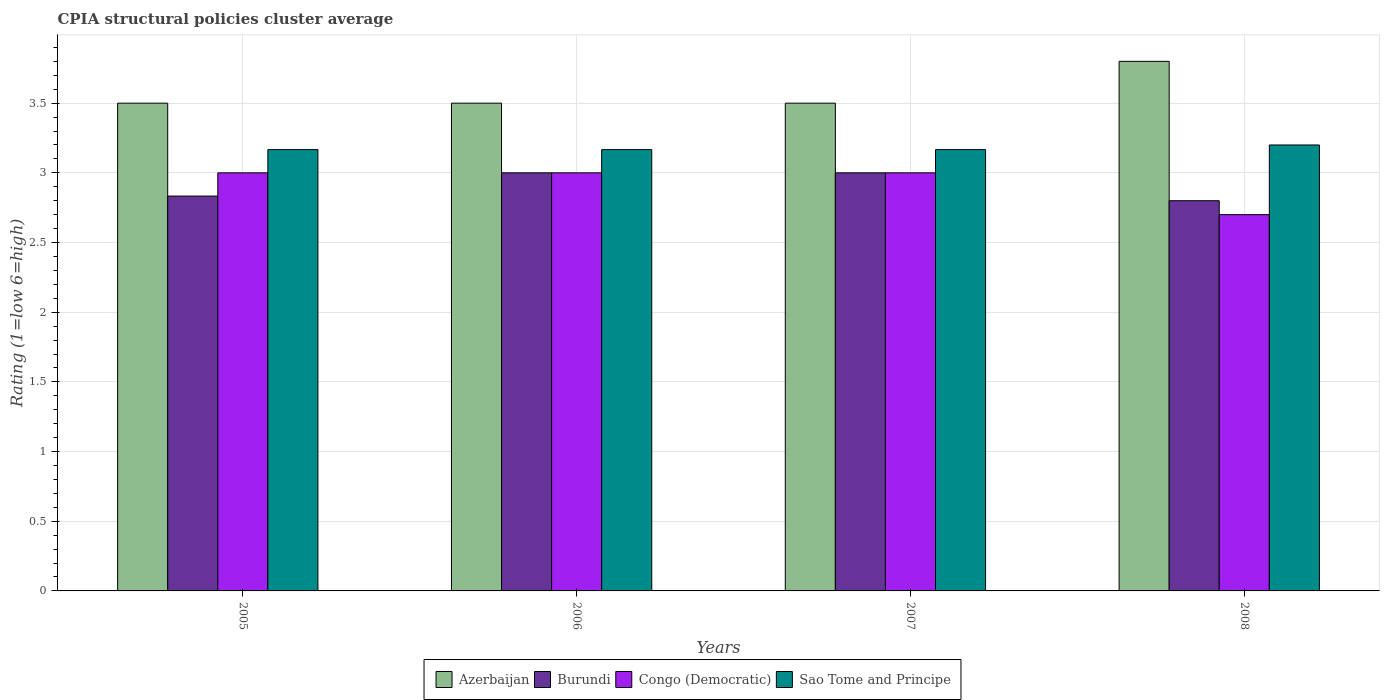How many different coloured bars are there?
Keep it short and to the point. 4. Are the number of bars per tick equal to the number of legend labels?
Offer a terse response. Yes. How many bars are there on the 4th tick from the right?
Your answer should be very brief. 4. What is the label of the 2nd group of bars from the left?
Offer a very short reply. 2006. Across all years, what is the maximum CPIA rating in Congo (Democratic)?
Make the answer very short. 3. Across all years, what is the minimum CPIA rating in Azerbaijan?
Provide a short and direct response. 3.5. In which year was the CPIA rating in Burundi minimum?
Offer a very short reply. 2008. What is the total CPIA rating in Congo (Democratic) in the graph?
Offer a terse response. 11.7. What is the difference between the CPIA rating in Azerbaijan in 2005 and that in 2006?
Keep it short and to the point. 0. What is the average CPIA rating in Sao Tome and Principe per year?
Your answer should be very brief. 3.18. In how many years, is the CPIA rating in Burundi greater than 0.6?
Ensure brevity in your answer.  4. What is the ratio of the CPIA rating in Azerbaijan in 2005 to that in 2008?
Your answer should be very brief. 0.92. What is the difference between the highest and the lowest CPIA rating in Burundi?
Ensure brevity in your answer.  0.2. Is the sum of the CPIA rating in Congo (Democratic) in 2006 and 2007 greater than the maximum CPIA rating in Azerbaijan across all years?
Keep it short and to the point. Yes. Is it the case that in every year, the sum of the CPIA rating in Azerbaijan and CPIA rating in Congo (Democratic) is greater than the sum of CPIA rating in Sao Tome and Principe and CPIA rating in Burundi?
Provide a succinct answer. No. What does the 2nd bar from the left in 2008 represents?
Provide a short and direct response. Burundi. What does the 2nd bar from the right in 2007 represents?
Ensure brevity in your answer.  Congo (Democratic). Is it the case that in every year, the sum of the CPIA rating in Sao Tome and Principe and CPIA rating in Azerbaijan is greater than the CPIA rating in Congo (Democratic)?
Give a very brief answer. Yes. Does the graph contain any zero values?
Keep it short and to the point. No. How are the legend labels stacked?
Offer a very short reply. Horizontal. What is the title of the graph?
Provide a succinct answer. CPIA structural policies cluster average. Does "Belize" appear as one of the legend labels in the graph?
Provide a short and direct response. No. What is the label or title of the X-axis?
Keep it short and to the point. Years. What is the label or title of the Y-axis?
Your answer should be compact. Rating (1=low 6=high). What is the Rating (1=low 6=high) of Azerbaijan in 2005?
Keep it short and to the point. 3.5. What is the Rating (1=low 6=high) in Burundi in 2005?
Offer a terse response. 2.83. What is the Rating (1=low 6=high) of Sao Tome and Principe in 2005?
Ensure brevity in your answer.  3.17. What is the Rating (1=low 6=high) in Burundi in 2006?
Give a very brief answer. 3. What is the Rating (1=low 6=high) in Congo (Democratic) in 2006?
Provide a succinct answer. 3. What is the Rating (1=low 6=high) in Sao Tome and Principe in 2006?
Your answer should be very brief. 3.17. What is the Rating (1=low 6=high) of Sao Tome and Principe in 2007?
Your response must be concise. 3.17. What is the Rating (1=low 6=high) in Burundi in 2008?
Your answer should be compact. 2.8. What is the Rating (1=low 6=high) of Congo (Democratic) in 2008?
Your response must be concise. 2.7. Across all years, what is the maximum Rating (1=low 6=high) in Azerbaijan?
Offer a very short reply. 3.8. Across all years, what is the minimum Rating (1=low 6=high) of Azerbaijan?
Ensure brevity in your answer.  3.5. Across all years, what is the minimum Rating (1=low 6=high) in Congo (Democratic)?
Offer a very short reply. 2.7. Across all years, what is the minimum Rating (1=low 6=high) of Sao Tome and Principe?
Make the answer very short. 3.17. What is the total Rating (1=low 6=high) of Burundi in the graph?
Give a very brief answer. 11.63. What is the total Rating (1=low 6=high) of Congo (Democratic) in the graph?
Ensure brevity in your answer.  11.7. What is the total Rating (1=low 6=high) of Sao Tome and Principe in the graph?
Your answer should be compact. 12.7. What is the difference between the Rating (1=low 6=high) of Sao Tome and Principe in 2005 and that in 2006?
Keep it short and to the point. 0. What is the difference between the Rating (1=low 6=high) in Burundi in 2005 and that in 2007?
Offer a terse response. -0.17. What is the difference between the Rating (1=low 6=high) of Congo (Democratic) in 2005 and that in 2007?
Your response must be concise. 0. What is the difference between the Rating (1=low 6=high) in Burundi in 2005 and that in 2008?
Your answer should be compact. 0.03. What is the difference between the Rating (1=low 6=high) in Congo (Democratic) in 2005 and that in 2008?
Make the answer very short. 0.3. What is the difference between the Rating (1=low 6=high) in Sao Tome and Principe in 2005 and that in 2008?
Offer a very short reply. -0.03. What is the difference between the Rating (1=low 6=high) of Burundi in 2006 and that in 2007?
Keep it short and to the point. 0. What is the difference between the Rating (1=low 6=high) of Burundi in 2006 and that in 2008?
Make the answer very short. 0.2. What is the difference between the Rating (1=low 6=high) in Congo (Democratic) in 2006 and that in 2008?
Your response must be concise. 0.3. What is the difference between the Rating (1=low 6=high) of Sao Tome and Principe in 2006 and that in 2008?
Provide a succinct answer. -0.03. What is the difference between the Rating (1=low 6=high) in Azerbaijan in 2007 and that in 2008?
Offer a very short reply. -0.3. What is the difference between the Rating (1=low 6=high) in Burundi in 2007 and that in 2008?
Provide a succinct answer. 0.2. What is the difference between the Rating (1=low 6=high) of Sao Tome and Principe in 2007 and that in 2008?
Ensure brevity in your answer.  -0.03. What is the difference between the Rating (1=low 6=high) of Azerbaijan in 2005 and the Rating (1=low 6=high) of Sao Tome and Principe in 2006?
Provide a short and direct response. 0.33. What is the difference between the Rating (1=low 6=high) in Burundi in 2005 and the Rating (1=low 6=high) in Sao Tome and Principe in 2006?
Give a very brief answer. -0.33. What is the difference between the Rating (1=low 6=high) in Congo (Democratic) in 2005 and the Rating (1=low 6=high) in Sao Tome and Principe in 2006?
Keep it short and to the point. -0.17. What is the difference between the Rating (1=low 6=high) of Azerbaijan in 2005 and the Rating (1=low 6=high) of Burundi in 2007?
Ensure brevity in your answer.  0.5. What is the difference between the Rating (1=low 6=high) of Azerbaijan in 2005 and the Rating (1=low 6=high) of Congo (Democratic) in 2007?
Offer a very short reply. 0.5. What is the difference between the Rating (1=low 6=high) of Azerbaijan in 2005 and the Rating (1=low 6=high) of Sao Tome and Principe in 2007?
Offer a terse response. 0.33. What is the difference between the Rating (1=low 6=high) in Burundi in 2005 and the Rating (1=low 6=high) in Congo (Democratic) in 2007?
Provide a short and direct response. -0.17. What is the difference between the Rating (1=low 6=high) of Burundi in 2005 and the Rating (1=low 6=high) of Sao Tome and Principe in 2007?
Make the answer very short. -0.33. What is the difference between the Rating (1=low 6=high) in Congo (Democratic) in 2005 and the Rating (1=low 6=high) in Sao Tome and Principe in 2007?
Keep it short and to the point. -0.17. What is the difference between the Rating (1=low 6=high) of Azerbaijan in 2005 and the Rating (1=low 6=high) of Burundi in 2008?
Provide a succinct answer. 0.7. What is the difference between the Rating (1=low 6=high) in Azerbaijan in 2005 and the Rating (1=low 6=high) in Congo (Democratic) in 2008?
Keep it short and to the point. 0.8. What is the difference between the Rating (1=low 6=high) in Azerbaijan in 2005 and the Rating (1=low 6=high) in Sao Tome and Principe in 2008?
Offer a very short reply. 0.3. What is the difference between the Rating (1=low 6=high) in Burundi in 2005 and the Rating (1=low 6=high) in Congo (Democratic) in 2008?
Keep it short and to the point. 0.13. What is the difference between the Rating (1=low 6=high) of Burundi in 2005 and the Rating (1=low 6=high) of Sao Tome and Principe in 2008?
Your answer should be very brief. -0.37. What is the difference between the Rating (1=low 6=high) of Congo (Democratic) in 2005 and the Rating (1=low 6=high) of Sao Tome and Principe in 2008?
Your answer should be compact. -0.2. What is the difference between the Rating (1=low 6=high) of Azerbaijan in 2006 and the Rating (1=low 6=high) of Burundi in 2007?
Provide a short and direct response. 0.5. What is the difference between the Rating (1=low 6=high) in Burundi in 2006 and the Rating (1=low 6=high) in Sao Tome and Principe in 2007?
Your answer should be very brief. -0.17. What is the difference between the Rating (1=low 6=high) of Congo (Democratic) in 2006 and the Rating (1=low 6=high) of Sao Tome and Principe in 2007?
Keep it short and to the point. -0.17. What is the difference between the Rating (1=low 6=high) in Azerbaijan in 2006 and the Rating (1=low 6=high) in Sao Tome and Principe in 2008?
Offer a terse response. 0.3. What is the difference between the Rating (1=low 6=high) in Burundi in 2006 and the Rating (1=low 6=high) in Congo (Democratic) in 2008?
Provide a short and direct response. 0.3. What is the difference between the Rating (1=low 6=high) of Congo (Democratic) in 2006 and the Rating (1=low 6=high) of Sao Tome and Principe in 2008?
Ensure brevity in your answer.  -0.2. What is the difference between the Rating (1=low 6=high) of Burundi in 2007 and the Rating (1=low 6=high) of Congo (Democratic) in 2008?
Provide a succinct answer. 0.3. What is the average Rating (1=low 6=high) in Azerbaijan per year?
Provide a succinct answer. 3.58. What is the average Rating (1=low 6=high) in Burundi per year?
Offer a terse response. 2.91. What is the average Rating (1=low 6=high) of Congo (Democratic) per year?
Offer a very short reply. 2.92. What is the average Rating (1=low 6=high) in Sao Tome and Principe per year?
Keep it short and to the point. 3.17. In the year 2005, what is the difference between the Rating (1=low 6=high) in Azerbaijan and Rating (1=low 6=high) in Sao Tome and Principe?
Keep it short and to the point. 0.33. In the year 2005, what is the difference between the Rating (1=low 6=high) in Burundi and Rating (1=low 6=high) in Congo (Democratic)?
Offer a terse response. -0.17. In the year 2005, what is the difference between the Rating (1=low 6=high) in Congo (Democratic) and Rating (1=low 6=high) in Sao Tome and Principe?
Ensure brevity in your answer.  -0.17. In the year 2006, what is the difference between the Rating (1=low 6=high) in Azerbaijan and Rating (1=low 6=high) in Congo (Democratic)?
Your answer should be compact. 0.5. In the year 2006, what is the difference between the Rating (1=low 6=high) of Azerbaijan and Rating (1=low 6=high) of Sao Tome and Principe?
Provide a succinct answer. 0.33. In the year 2006, what is the difference between the Rating (1=low 6=high) in Congo (Democratic) and Rating (1=low 6=high) in Sao Tome and Principe?
Provide a short and direct response. -0.17. In the year 2007, what is the difference between the Rating (1=low 6=high) of Azerbaijan and Rating (1=low 6=high) of Congo (Democratic)?
Your response must be concise. 0.5. In the year 2007, what is the difference between the Rating (1=low 6=high) in Azerbaijan and Rating (1=low 6=high) in Sao Tome and Principe?
Give a very brief answer. 0.33. In the year 2007, what is the difference between the Rating (1=low 6=high) of Burundi and Rating (1=low 6=high) of Congo (Democratic)?
Your response must be concise. 0. In the year 2008, what is the difference between the Rating (1=low 6=high) of Azerbaijan and Rating (1=low 6=high) of Congo (Democratic)?
Your answer should be very brief. 1.1. In the year 2008, what is the difference between the Rating (1=low 6=high) of Burundi and Rating (1=low 6=high) of Sao Tome and Principe?
Provide a short and direct response. -0.4. In the year 2008, what is the difference between the Rating (1=low 6=high) of Congo (Democratic) and Rating (1=low 6=high) of Sao Tome and Principe?
Ensure brevity in your answer.  -0.5. What is the ratio of the Rating (1=low 6=high) of Sao Tome and Principe in 2005 to that in 2006?
Offer a very short reply. 1. What is the ratio of the Rating (1=low 6=high) of Azerbaijan in 2005 to that in 2008?
Give a very brief answer. 0.92. What is the ratio of the Rating (1=low 6=high) of Burundi in 2005 to that in 2008?
Keep it short and to the point. 1.01. What is the ratio of the Rating (1=low 6=high) of Congo (Democratic) in 2005 to that in 2008?
Keep it short and to the point. 1.11. What is the ratio of the Rating (1=low 6=high) in Azerbaijan in 2006 to that in 2007?
Ensure brevity in your answer.  1. What is the ratio of the Rating (1=low 6=high) in Congo (Democratic) in 2006 to that in 2007?
Offer a terse response. 1. What is the ratio of the Rating (1=low 6=high) of Sao Tome and Principe in 2006 to that in 2007?
Provide a short and direct response. 1. What is the ratio of the Rating (1=low 6=high) in Azerbaijan in 2006 to that in 2008?
Your answer should be compact. 0.92. What is the ratio of the Rating (1=low 6=high) in Burundi in 2006 to that in 2008?
Provide a short and direct response. 1.07. What is the ratio of the Rating (1=low 6=high) of Congo (Democratic) in 2006 to that in 2008?
Your answer should be compact. 1.11. What is the ratio of the Rating (1=low 6=high) in Azerbaijan in 2007 to that in 2008?
Make the answer very short. 0.92. What is the ratio of the Rating (1=low 6=high) of Burundi in 2007 to that in 2008?
Offer a very short reply. 1.07. What is the ratio of the Rating (1=low 6=high) in Sao Tome and Principe in 2007 to that in 2008?
Provide a succinct answer. 0.99. What is the difference between the highest and the second highest Rating (1=low 6=high) in Congo (Democratic)?
Give a very brief answer. 0. What is the difference between the highest and the lowest Rating (1=low 6=high) of Azerbaijan?
Your response must be concise. 0.3. What is the difference between the highest and the lowest Rating (1=low 6=high) in Sao Tome and Principe?
Make the answer very short. 0.03. 